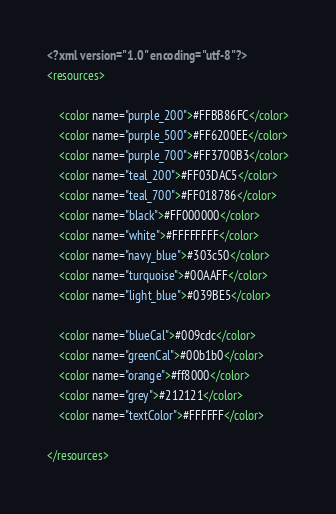<code> <loc_0><loc_0><loc_500><loc_500><_XML_><?xml version="1.0" encoding="utf-8"?>
<resources>

    <color name="purple_200">#FFBB86FC</color>
    <color name="purple_500">#FF6200EE</color>
    <color name="purple_700">#FF3700B3</color>
    <color name="teal_200">#FF03DAC5</color>
    <color name="teal_700">#FF018786</color>
    <color name="black">#FF000000</color>
    <color name="white">#FFFFFFFF</color>
    <color name="navy_blue">#303c50</color>
    <color name="turquoise">#00AAFF</color>
    <color name="light_blue">#039BE5</color>

    <color name="blueCal">#009cdc</color>
    <color name="greenCal">#00b1b0</color>
    <color name="orange">#ff8000</color>
    <color name="grey">#212121</color>
    <color name="textColor">#FFFFFF</color>

</resources></code> 